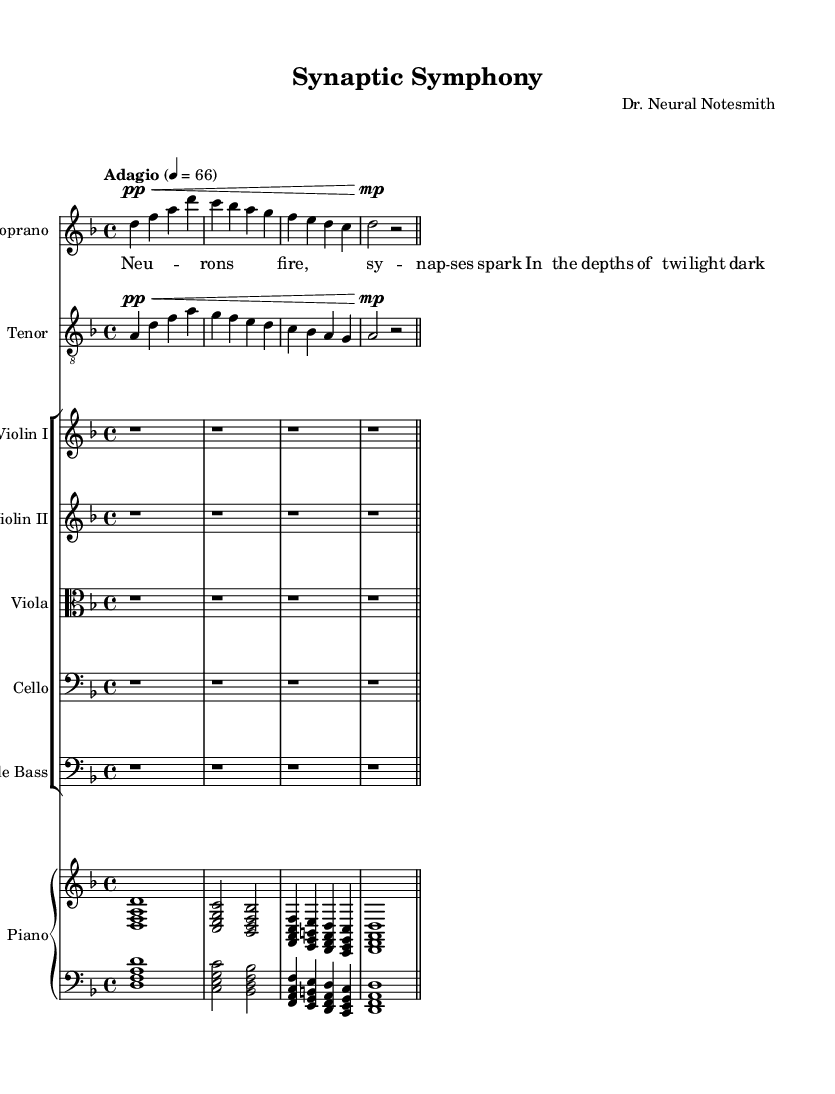What is the key signature of this music? The key signature is indicated by the symbols at the beginning of the staff. Here, there are no sharps or flats shown, which means the piece is in D minor, as stated in the global setup.
Answer: D minor What is the time signature of this music? The time signature is located at the beginning of the music staff, right after the key signature. It is written as "4/4," indicating four beats per measure.
Answer: 4/4 What is the tempo marking for this music piece? The tempo is indicated below the global setup and states "Adagio" with a metronome marking of 4 = 66. This suggests a slow and smooth pace for the performance.
Answer: Adagio How many measures does the soprano part contain? Counting the bar lines in the soprano part shows there are four measures present. Each measure is separated by a vertical line, making it easy to identify.
Answer: 4 What dynamics are indicated for the tenor part? The dynamics for the tenor part are specified at the beginning of the musical notation. The marking shows a very soft level indicated as "pp," which means pianissimo.
Answer: pp What unique thematic aspect does the title "Synaptic Symphony" suggest about the opera? The title implies a focus on the idea of neuron interactions and the complexities of neurological disorders, which aligns with the opera's theme regarding the intricacies of the brain, highlighting its dramatic nature.
Answer: Neuron interactions What is the function of the piano part in relation to the vocal lines? The piano part typically functions to accompany the vocal lines, enriching the harmonization and providing a fuller sound to support the melodies sung by the soprano and tenor parts.
Answer: Accompaniment 